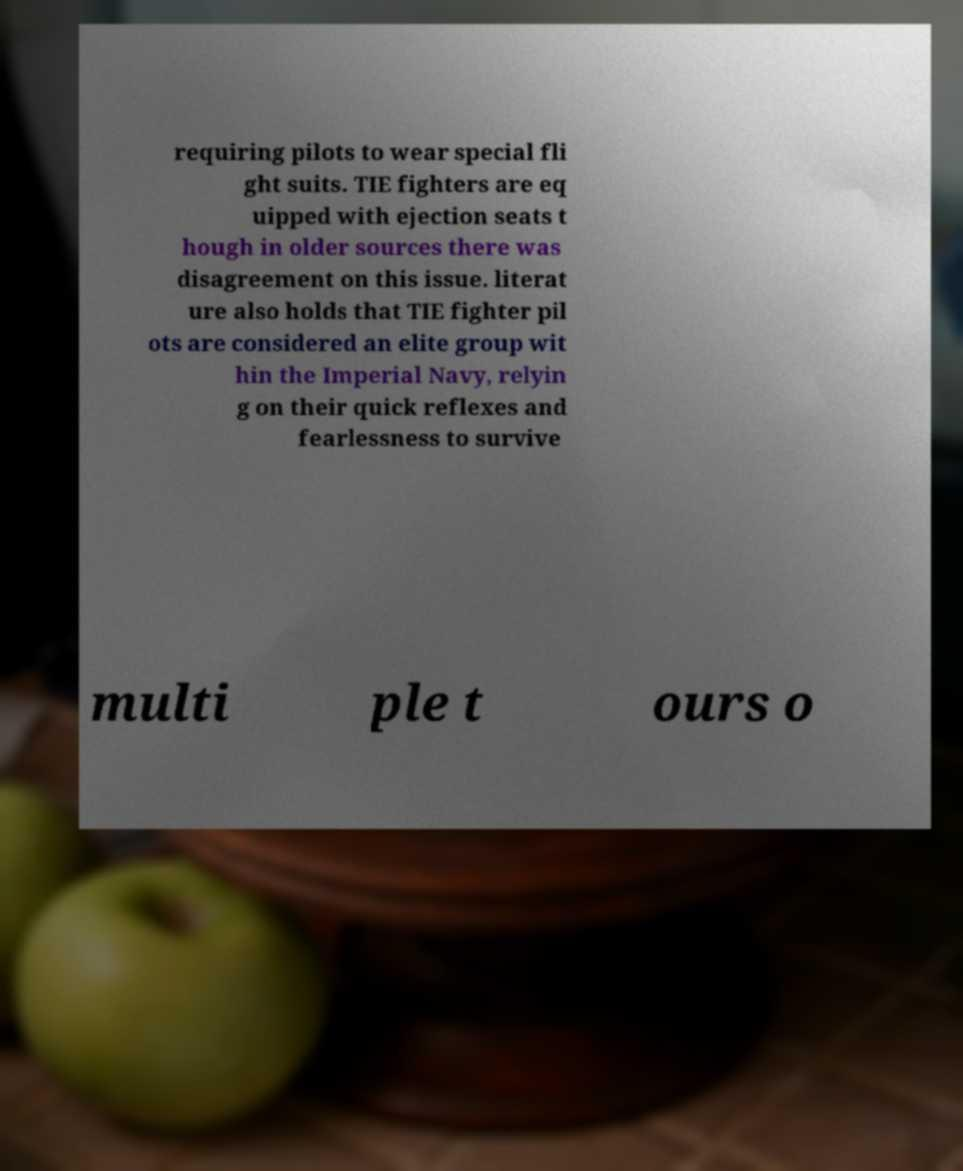What messages or text are displayed in this image? I need them in a readable, typed format. requiring pilots to wear special fli ght suits. TIE fighters are eq uipped with ejection seats t hough in older sources there was disagreement on this issue. literat ure also holds that TIE fighter pil ots are considered an elite group wit hin the Imperial Navy, relyin g on their quick reflexes and fearlessness to survive multi ple t ours o 